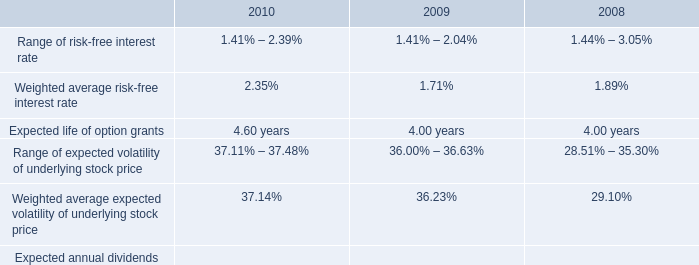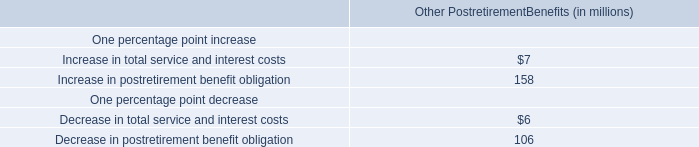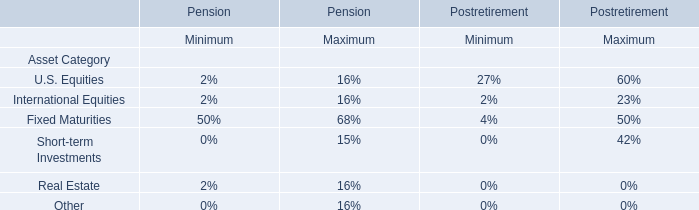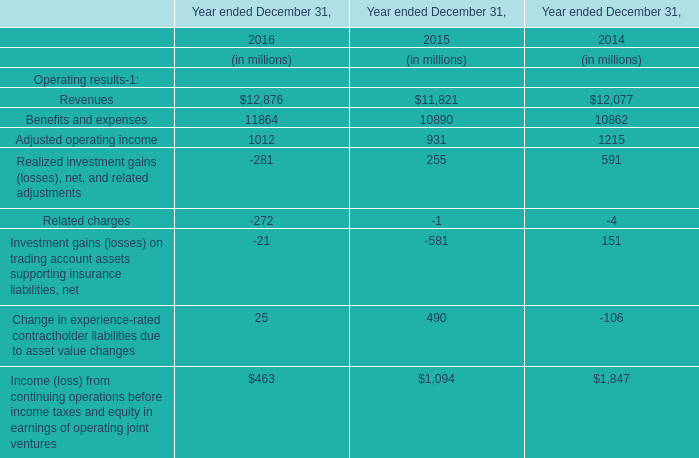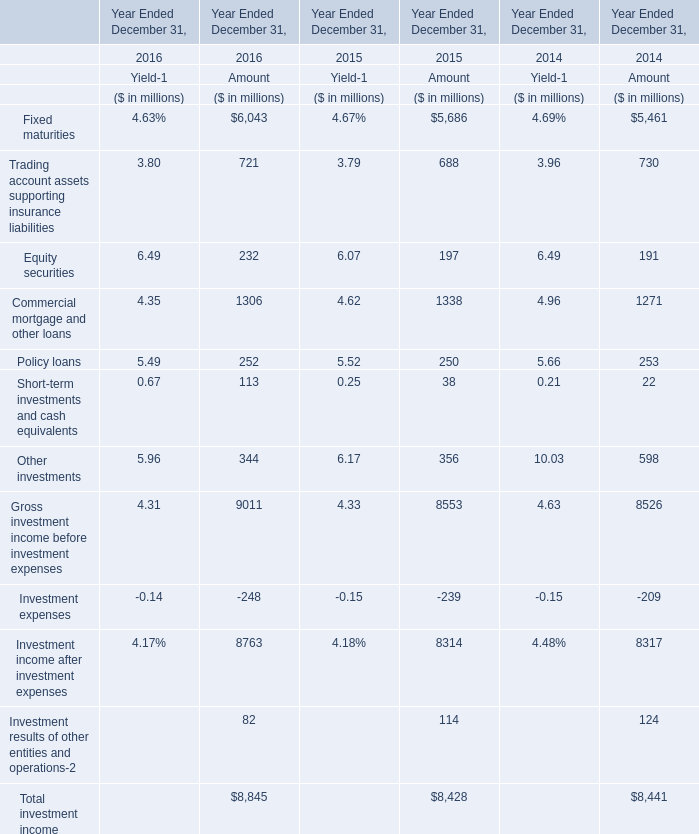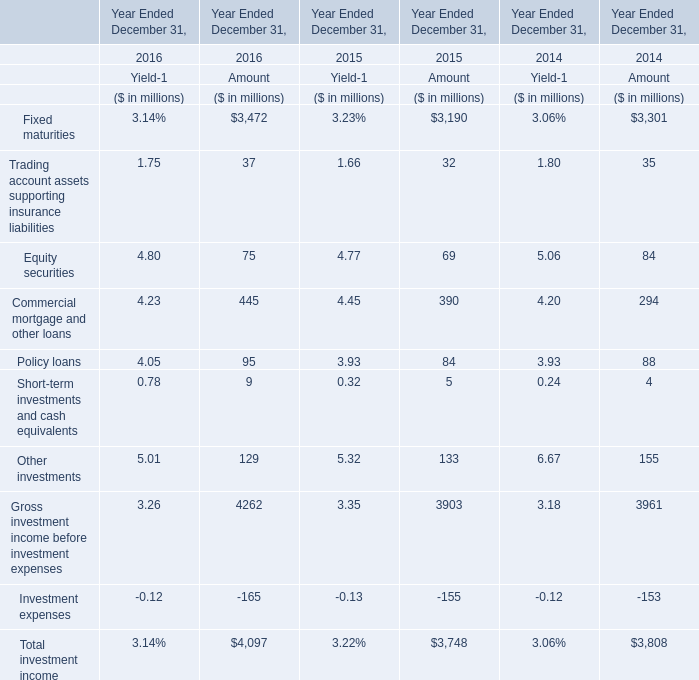What is the sum of rading account assets supporting insurance liabilities in 2016? (in million) 
Computations: (3.8 + 721)
Answer: 724.8. 